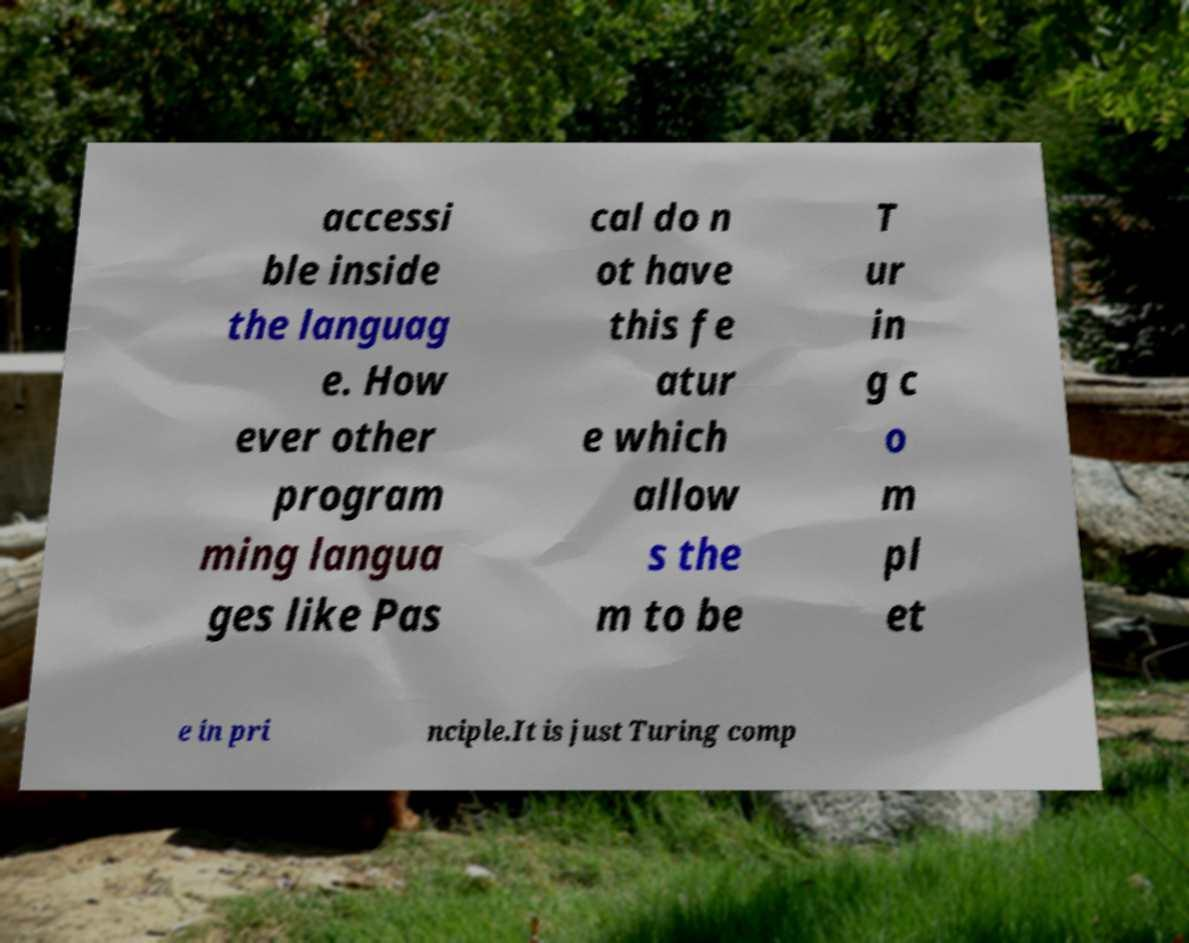For documentation purposes, I need the text within this image transcribed. Could you provide that? accessi ble inside the languag e. How ever other program ming langua ges like Pas cal do n ot have this fe atur e which allow s the m to be T ur in g c o m pl et e in pri nciple.It is just Turing comp 